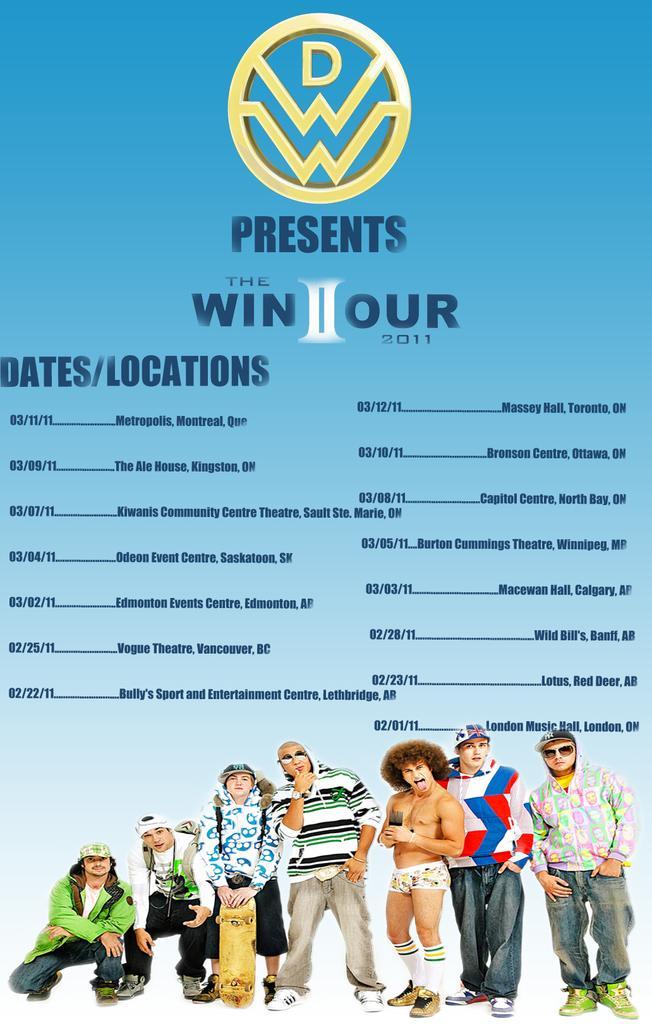Could you give a brief overview of what you see in this image? In this image we can see there is a poster with some text, logo and a few people. 